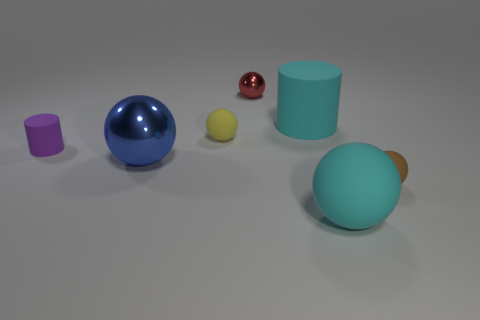Subtract all blue balls. How many balls are left? 4 Subtract all small yellow rubber spheres. How many spheres are left? 4 Add 1 big cyan things. How many objects exist? 8 Subtract all brown balls. Subtract all red cylinders. How many balls are left? 4 Subtract all cylinders. How many objects are left? 5 Subtract all small red metallic spheres. Subtract all yellow objects. How many objects are left? 5 Add 5 metal balls. How many metal balls are left? 7 Add 5 cyan matte balls. How many cyan matte balls exist? 6 Subtract 0 brown cylinders. How many objects are left? 7 